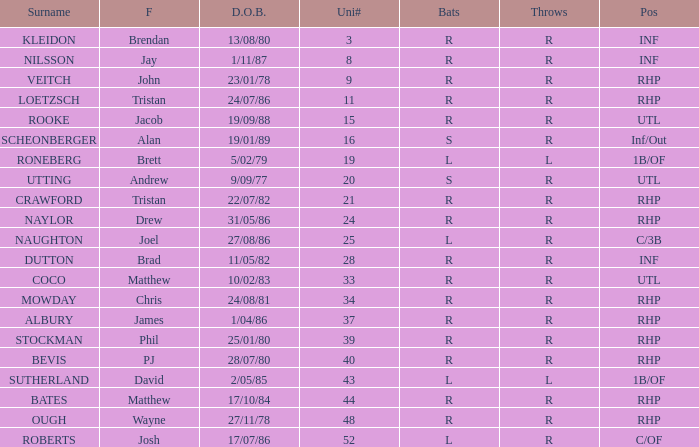How many Uni numbers have Bats of s, and a Position of utl? 1.0. 